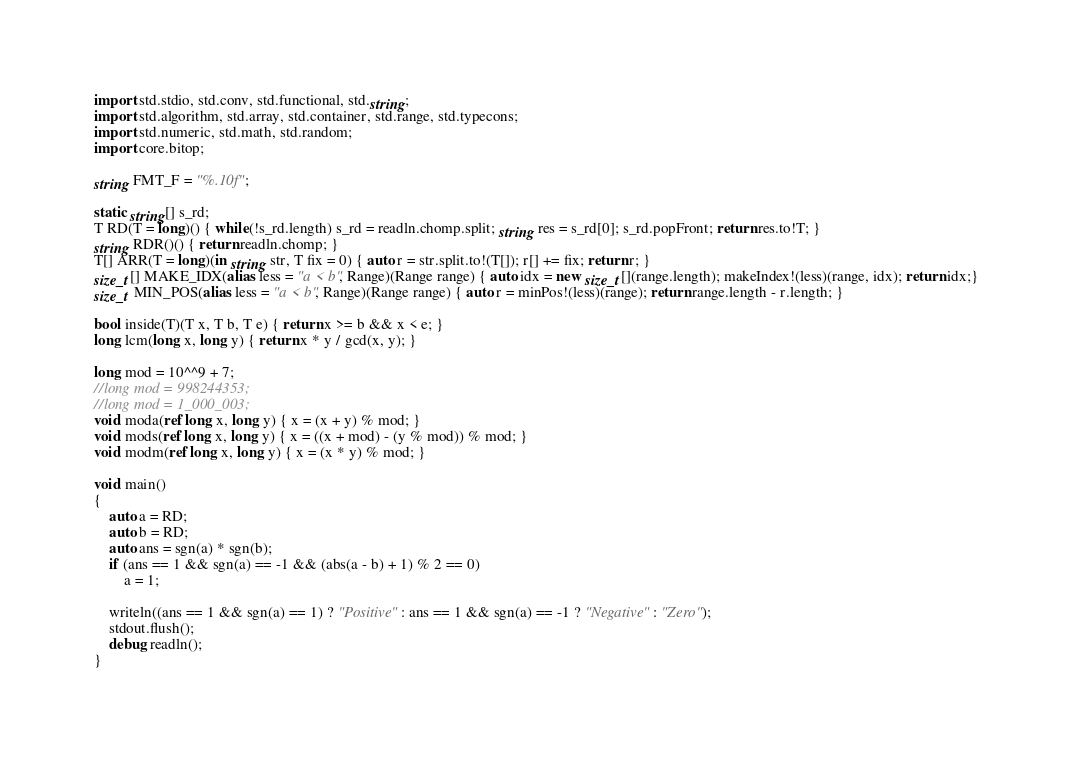<code> <loc_0><loc_0><loc_500><loc_500><_D_>import std.stdio, std.conv, std.functional, std.string;
import std.algorithm, std.array, std.container, std.range, std.typecons;
import std.numeric, std.math, std.random;
import core.bitop;

string FMT_F = "%.10f";

static string[] s_rd;
T RD(T = long)() { while(!s_rd.length) s_rd = readln.chomp.split; string res = s_rd[0]; s_rd.popFront; return res.to!T; }
string RDR()() { return readln.chomp; }
T[] ARR(T = long)(in string str, T fix = 0) { auto r = str.split.to!(T[]); r[] += fix; return r; }
size_t[] MAKE_IDX(alias less = "a < b", Range)(Range range) { auto idx = new size_t[](range.length); makeIndex!(less)(range, idx); return idx;}
size_t MIN_POS(alias less = "a < b", Range)(Range range) { auto r = minPos!(less)(range); return range.length - r.length; }

bool inside(T)(T x, T b, T e) { return x >= b && x < e; }
long lcm(long x, long y) { return x * y / gcd(x, y); }

long mod = 10^^9 + 7;
//long mod = 998244353;
//long mod = 1_000_003;
void moda(ref long x, long y) { x = (x + y) % mod; }
void mods(ref long x, long y) { x = ((x + mod) - (y % mod)) % mod; }
void modm(ref long x, long y) { x = (x * y) % mod; }

void main()
{
	auto a = RD;
	auto b = RD;
	auto ans = sgn(a) * sgn(b);
	if (ans == 1 && sgn(a) == -1 && (abs(a - b) + 1) % 2 == 0)
		a = 1;
	
	writeln((ans == 1 && sgn(a) == 1) ? "Positive" : ans == 1 && sgn(a) == -1 ? "Negative" : "Zero");
	stdout.flush();
	debug readln();
}
</code> 